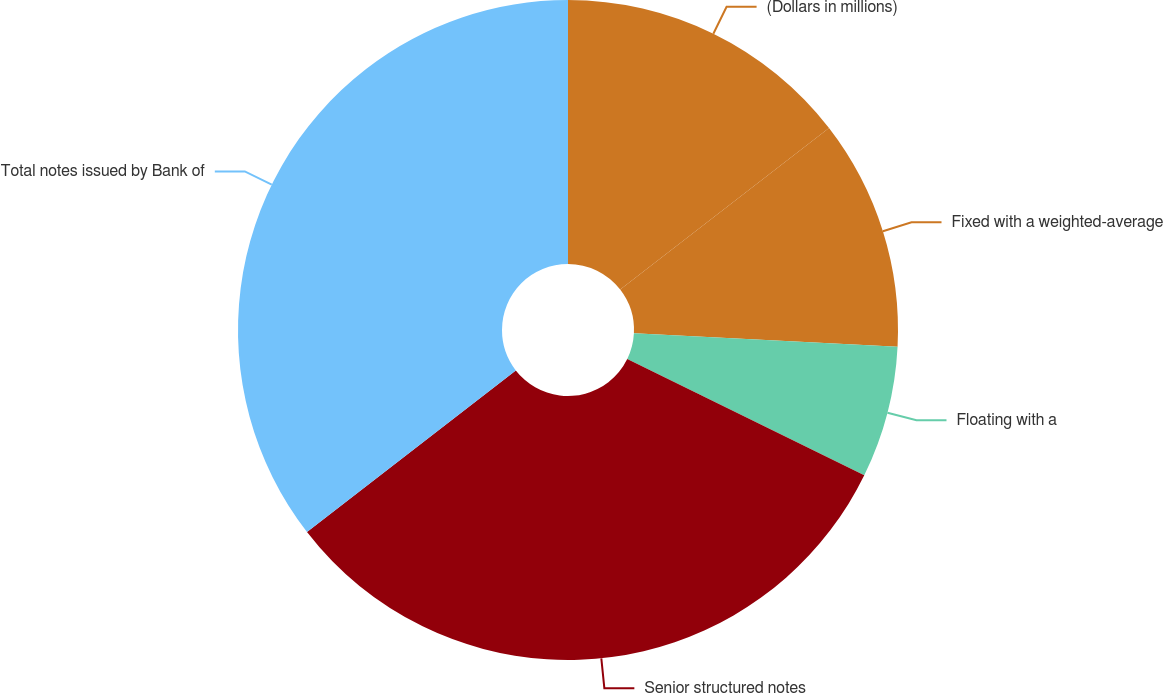Convert chart. <chart><loc_0><loc_0><loc_500><loc_500><pie_chart><fcel>(Dollars in millions)<fcel>Fixed with a weighted-average<fcel>Floating with a<fcel>Senior structured notes<fcel>Total notes issued by Bank of<nl><fcel>14.52%<fcel>11.29%<fcel>6.45%<fcel>32.26%<fcel>35.48%<nl></chart> 